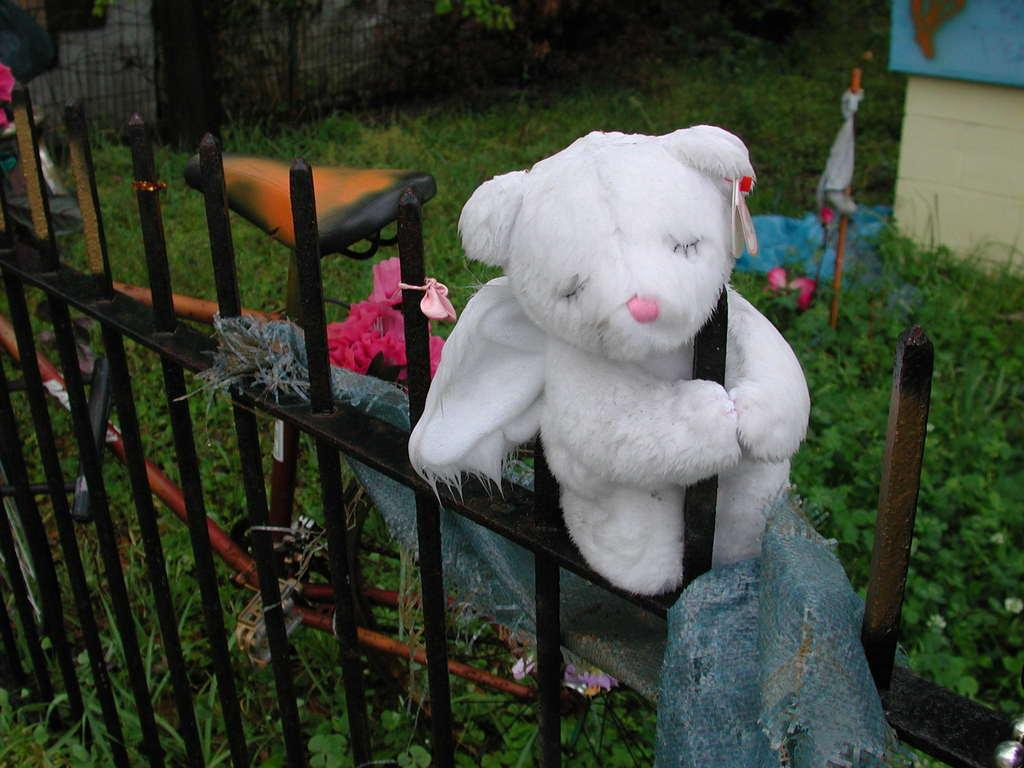What type of barrier can be seen in the image? There is a metal fence in the image. What is placed on the metal fence? A toy and a cloth are present on the metal fence. What type of vehicle is visible in the image? There is a cycle in the image. What type of vegetation is visible at the bottom of the image? Grass is visible at the bottom of the image. Where is the quince stored in the image? There is no quince present in the image. Can you describe the twig that is holding the toy on the metal fence? There is no twig mentioned in the image; the toy is simply placed on the metal fence. 